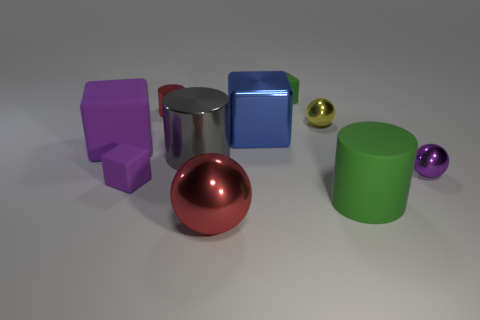How many blue things are big rubber blocks or big balls? In the image, there are no big blue rubber blocks or balls. However, there is one large blue object that appears to be a shiny metal cube. 